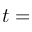Convert formula to latex. <formula><loc_0><loc_0><loc_500><loc_500>t =</formula> 